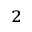Convert formula to latex. <formula><loc_0><loc_0><loc_500><loc_500>^ { 2 }</formula> 